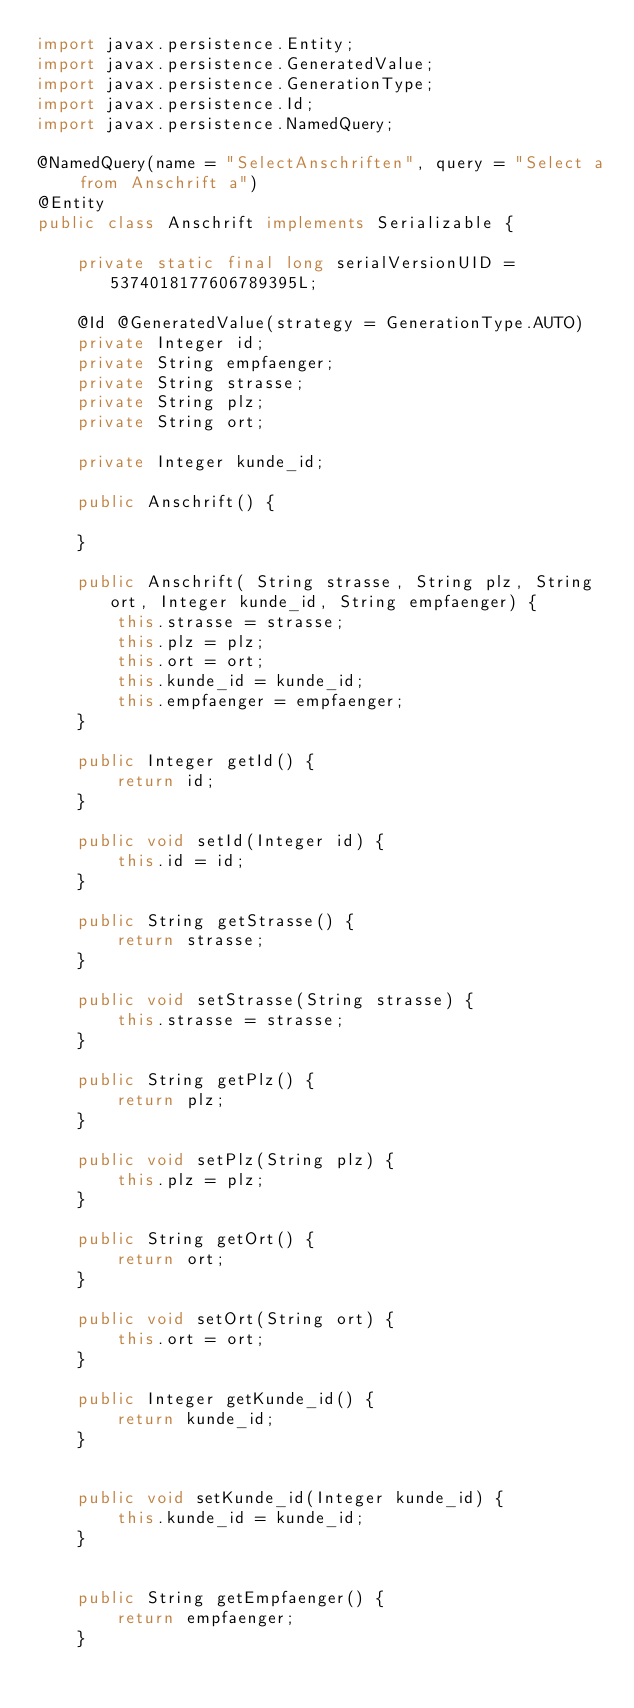<code> <loc_0><loc_0><loc_500><loc_500><_Java_>import javax.persistence.Entity;
import javax.persistence.GeneratedValue;
import javax.persistence.GenerationType;
import javax.persistence.Id;
import javax.persistence.NamedQuery;

@NamedQuery(name = "SelectAnschriften", query = "Select a from Anschrift a")
@Entity
public class Anschrift implements Serializable {

	private static final long serialVersionUID = 5374018177606789395L;
	
	@Id @GeneratedValue(strategy = GenerationType.AUTO)
	private Integer id;
	private String empfaenger;
	private String strasse;
	private String plz;
	private String ort;
	
	private Integer kunde_id;

	public Anschrift() {
	
	}
		
	public Anschrift( String strasse, String plz, String ort, Integer kunde_id, String empfaenger) {
		this.strasse = strasse;
		this.plz = plz;
		this.ort = ort;
		this.kunde_id = kunde_id;
		this.empfaenger = empfaenger;
	}

	public Integer getId() {
		return id;
	}

	public void setId(Integer id) {
		this.id = id;
	}

	public String getStrasse() {
		return strasse;
	}

	public void setStrasse(String strasse) {
		this.strasse = strasse;
	}

	public String getPlz() {
		return plz;
	}

	public void setPlz(String plz) {
		this.plz = plz;
	}

	public String getOrt() {
		return ort;
	}

	public void setOrt(String ort) {
		this.ort = ort;
	}

	public Integer getKunde_id() {
		return kunde_id;
	}


	public void setKunde_id(Integer kunde_id) {
		this.kunde_id = kunde_id;
	}


	public String getEmpfaenger() {
		return empfaenger;
	}

</code> 